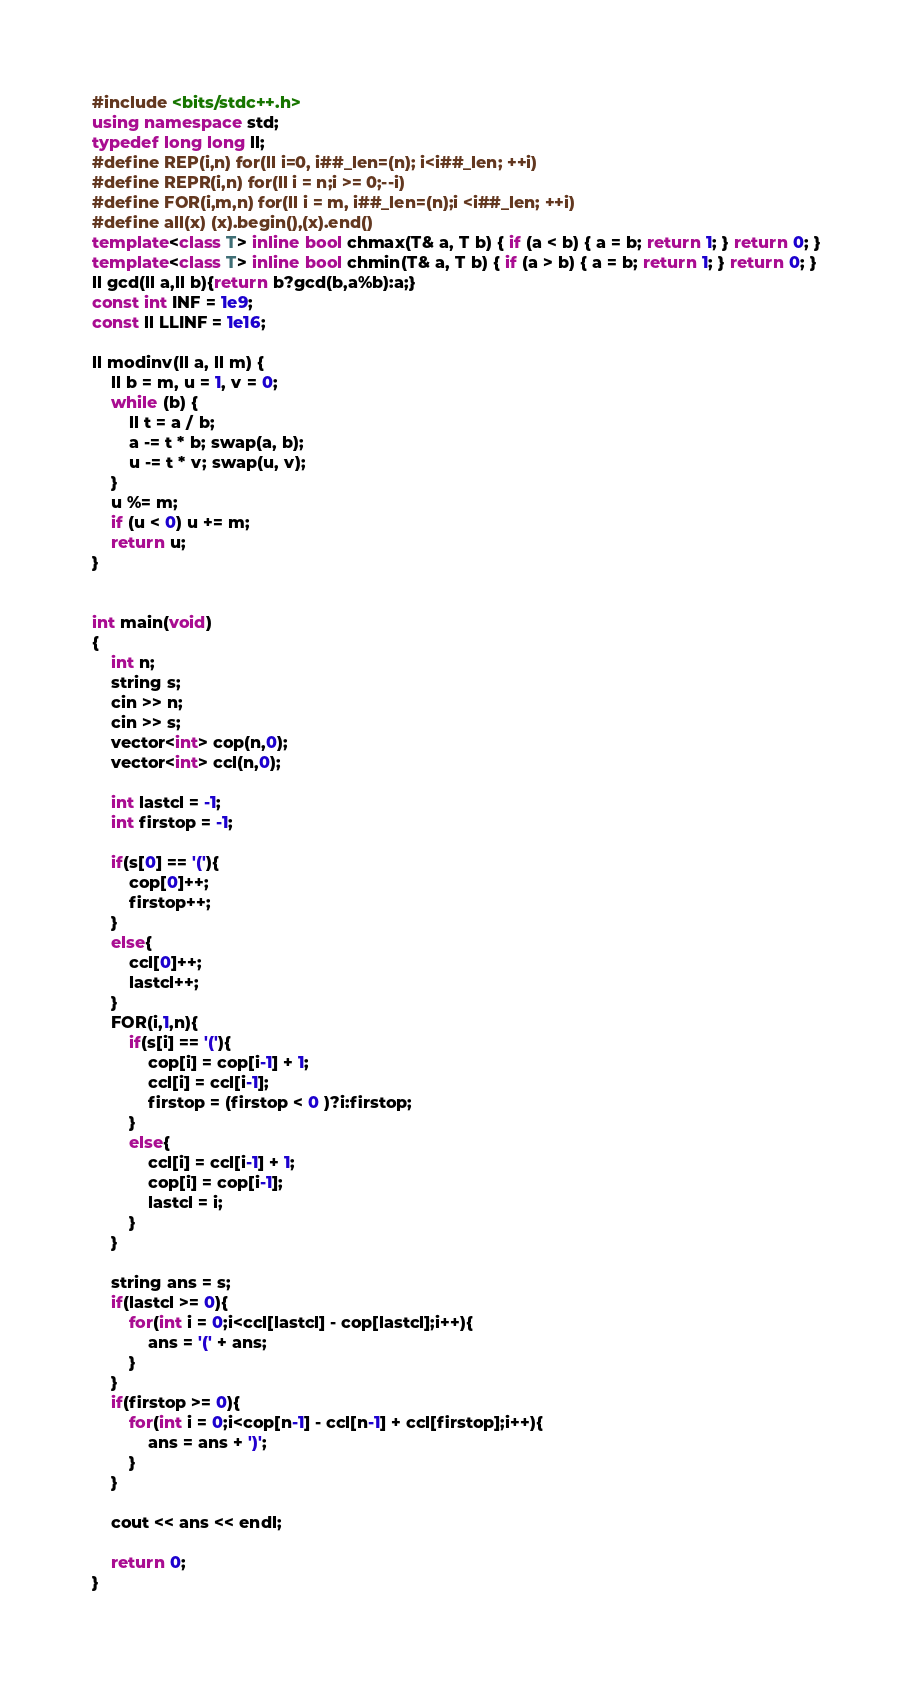<code> <loc_0><loc_0><loc_500><loc_500><_C++_>#include <bits/stdc++.h>
using namespace std;
typedef long long ll;
#define REP(i,n) for(ll i=0, i##_len=(n); i<i##_len; ++i)
#define REPR(i,n) for(ll i = n;i >= 0;--i)
#define FOR(i,m,n) for(ll i = m, i##_len=(n);i <i##_len; ++i)
#define all(x) (x).begin(),(x).end()
template<class T> inline bool chmax(T& a, T b) { if (a < b) { a = b; return 1; } return 0; }
template<class T> inline bool chmin(T& a, T b) { if (a > b) { a = b; return 1; } return 0; }
ll gcd(ll a,ll b){return b?gcd(b,a%b):a;}
const int INF = 1e9;
const ll LLINF = 1e16;

ll modinv(ll a, ll m) {
    ll b = m, u = 1, v = 0;
    while (b) {
        ll t = a / b;
        a -= t * b; swap(a, b);
        u -= t * v; swap(u, v);
    }
    u %= m;
    if (u < 0) u += m;
    return u;
}


int main(void)
{
    int n;
    string s;
    cin >> n;
    cin >> s;
    vector<int> cop(n,0);
    vector<int> ccl(n,0);

    int lastcl = -1;
    int firstop = -1;

    if(s[0] == '('){
        cop[0]++;
        firstop++;
    }
    else{
        ccl[0]++;
        lastcl++;        
    }
    FOR(i,1,n){
        if(s[i] == '('){
            cop[i] = cop[i-1] + 1;
            ccl[i] = ccl[i-1];
            firstop = (firstop < 0 )?i:firstop;
        }
        else{
            ccl[i] = ccl[i-1] + 1;
            cop[i] = cop[i-1];
            lastcl = i;
        }
    }

    string ans = s;
    if(lastcl >= 0){
        for(int i = 0;i<ccl[lastcl] - cop[lastcl];i++){
            ans = '(' + ans;
        }
    }
    if(firstop >= 0){
        for(int i = 0;i<cop[n-1] - ccl[n-1] + ccl[firstop];i++){
            ans = ans + ')';
        }
    }

    cout << ans << endl;

    return 0;
}</code> 